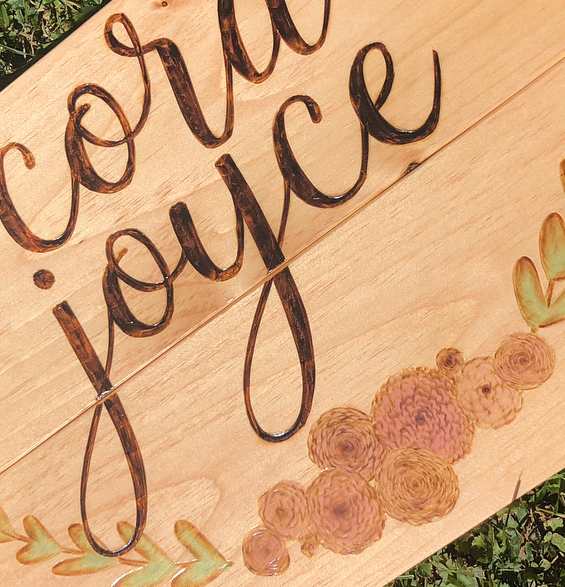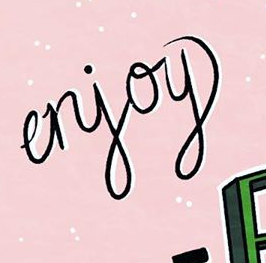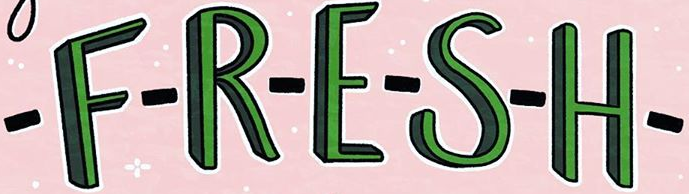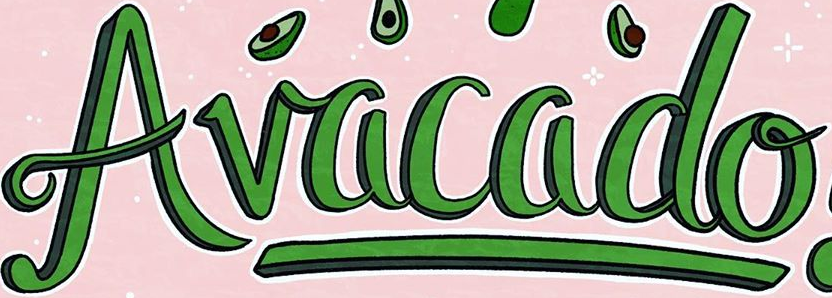What words can you see in these images in sequence, separated by a semicolon? joyce; erjoy; -F-R-E-S-H-; Avacado 